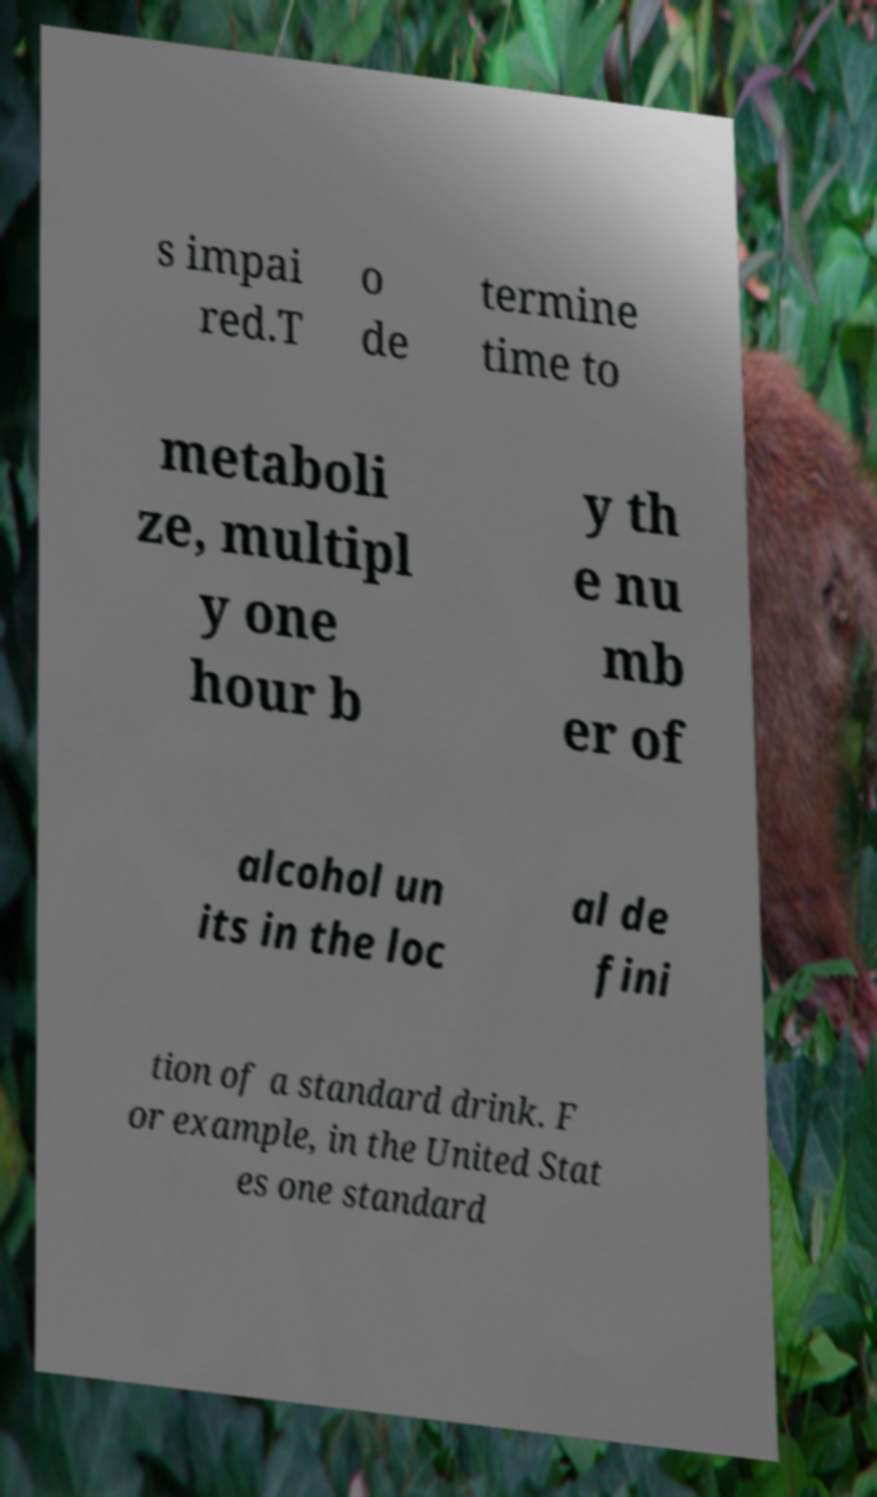What messages or text are displayed in this image? I need them in a readable, typed format. s impai red.T o de termine time to metaboli ze, multipl y one hour b y th e nu mb er of alcohol un its in the loc al de fini tion of a standard drink. F or example, in the United Stat es one standard 